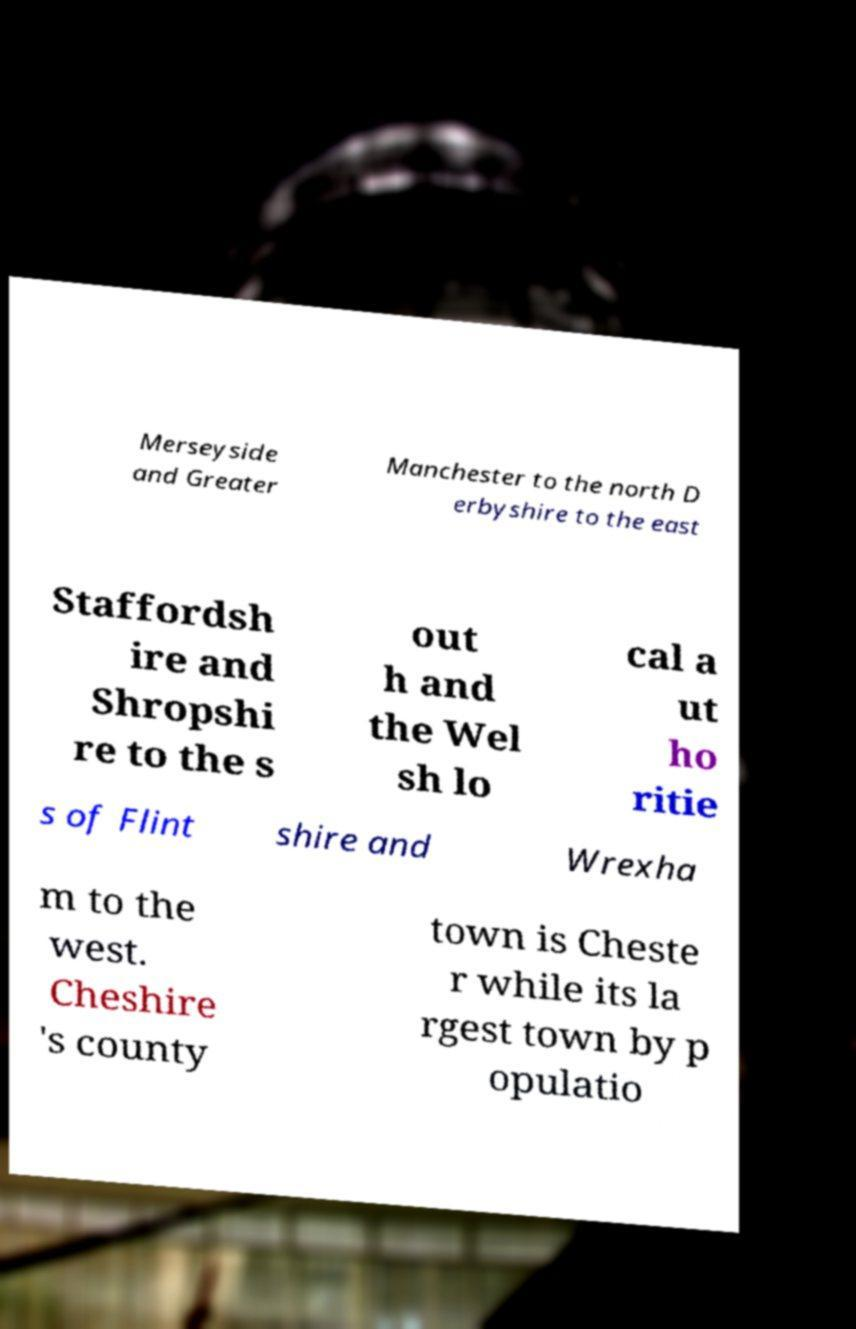Can you read and provide the text displayed in the image?This photo seems to have some interesting text. Can you extract and type it out for me? Merseyside and Greater Manchester to the north D erbyshire to the east Staffordsh ire and Shropshi re to the s out h and the Wel sh lo cal a ut ho ritie s of Flint shire and Wrexha m to the west. Cheshire 's county town is Cheste r while its la rgest town by p opulatio 